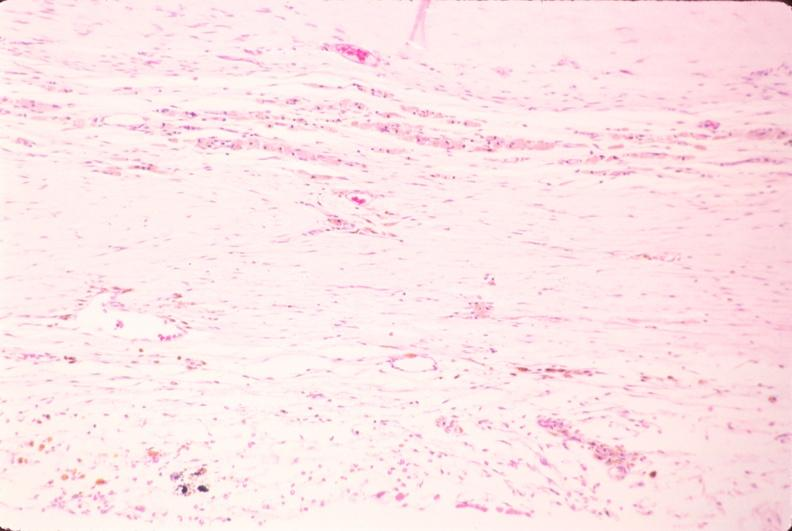does this image show brain, infarct due to ruptured saccular aneurysm and thrombosis of right middle cerebral artery?
Answer the question using a single word or phrase. Yes 